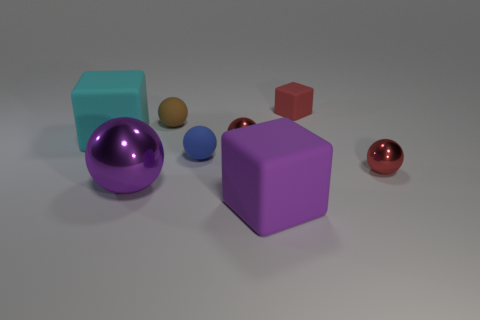The other large thing that is the same shape as the purple matte thing is what color?
Offer a very short reply. Cyan. Is the size of the red ball that is behind the tiny blue ball the same as the brown object that is behind the big shiny sphere?
Keep it short and to the point. Yes. There is a blue matte object; is it the same size as the rubber object on the right side of the large purple rubber thing?
Your answer should be very brief. Yes. What is the size of the cyan rubber block?
Your answer should be very brief. Large. There is a tiny cube that is made of the same material as the tiny blue object; what color is it?
Give a very brief answer. Red. How many purple spheres are the same material as the tiny red block?
Keep it short and to the point. 0. What number of things are either big purple things or tiny red objects that are on the right side of the tiny red matte cube?
Ensure brevity in your answer.  3. Does the small red object behind the large cyan cube have the same material as the small blue thing?
Your answer should be very brief. Yes. There is a block that is the same size as the blue matte object; what is its color?
Offer a very short reply. Red. Are there any tiny red things of the same shape as the big shiny thing?
Offer a terse response. Yes. 